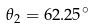Convert formula to latex. <formula><loc_0><loc_0><loc_500><loc_500>\theta _ { 2 } = 6 2 . 2 5 ^ { \circ }</formula> 